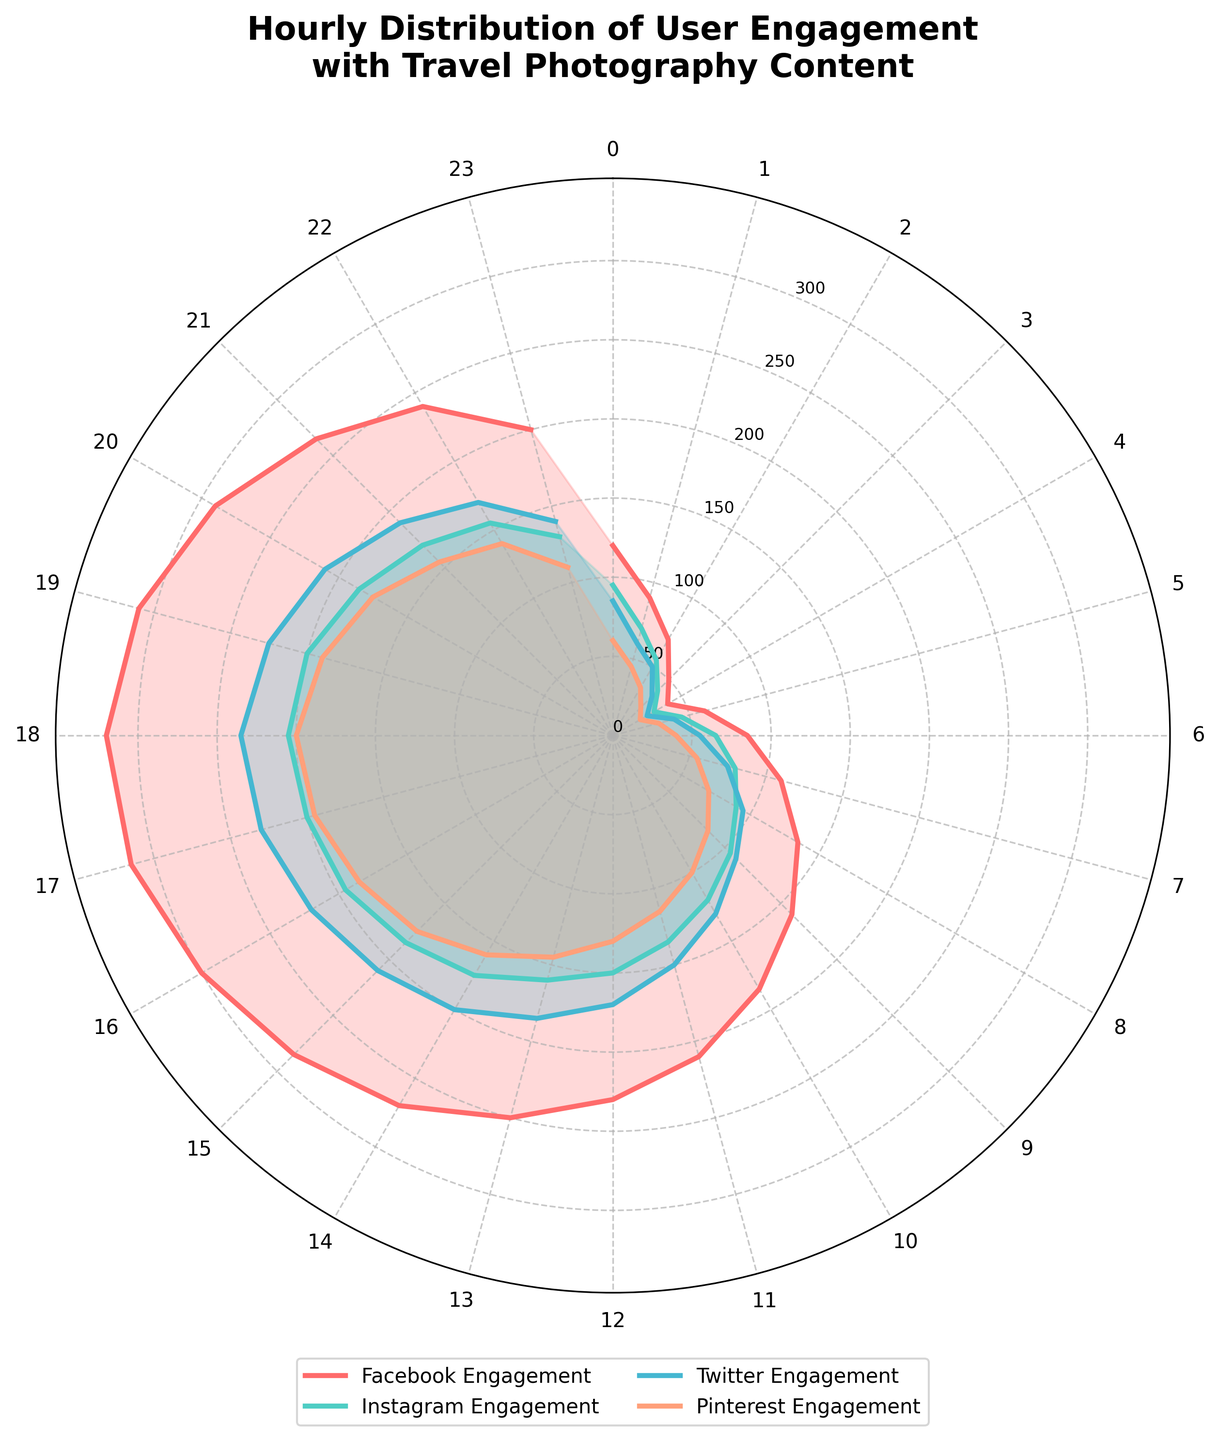What is the title of the figure? The title is typically centered at the top of the figure and often uses a larger or bold font to stand out.
Answer: Hourly Distribution of User Engagement with Travel Photography Content How many distinct platforms are displayed in the figure? By observing the legend, we can see the number of unique entries correlating to the different platforms. Each platform is represented by a different color and name in the legend.
Answer: 4 At what hour does Facebook engagement peak? Using the figure, we look for the hour where the Facebook engagement (often marked by a specific color as indicated in the legend) is highest.
Answer: 18 During what hour range is Twitter engagement consistently increasing? Observing the Twitter engagement line on the plot, we follow from one hour to the next, tracking when the values are continuously going up.
Answer: 0 to 18 Which platform has the least engagement at 3 AM? Referring to the data points at the 3 AM mark for each platform (as indicated in their respective lines on the plot), we compare the values.
Answer: Pinterest How does Instagram engagement at 9 AM compare to Twitter engagement at the same hour? By locating the 9 AM mark on the plot for both Instagram and Twitter, we compare the engagement values.
Answer: Instagram engagement is greater What is the range of engagement values for Pinterest throughout the day? Looking at the minimum and maximum values of Pinterest engagement from the plot. The lowest and highest points on the Pinterest line give us the range.
Answer: 20 to 200 What hour experiences the sharpest rise in Facebook engagement? Observing the figure for the steepest slope in the Facebook engagement line indicates where the largest increase happens between consecutive hours.
Answer: 0 to 1 PM At what hour does the sum of all platform engagements reach its maximum? By summing the engagement values of all platforms for each hour and then identifying the hour with the largest total, we can determine this.
Answer: 18 Do any platforms show a decrease in engagement from 6 PM to 7 PM? By comparing the engagement levels for each platform at the 6 PM and 7 PM marks, we identify any decreases in the values.
Answer: Facebook and Twitter 